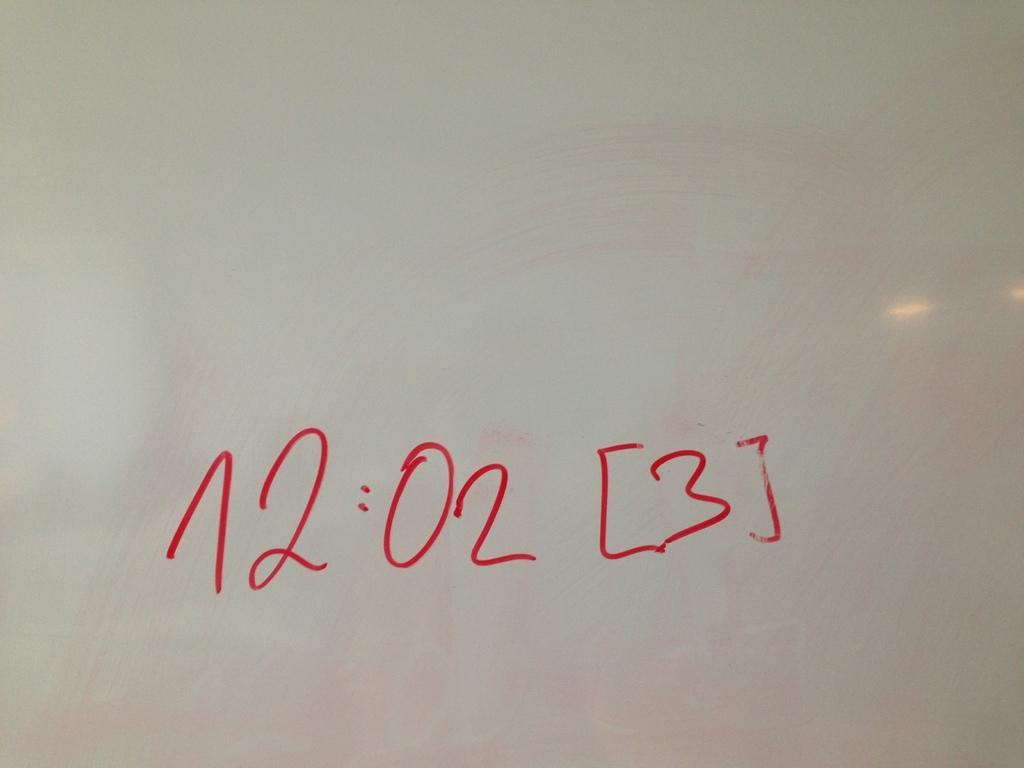<image>
Provide a brief description of the given image. A white board has the red writing 12:02 [3] on it. 